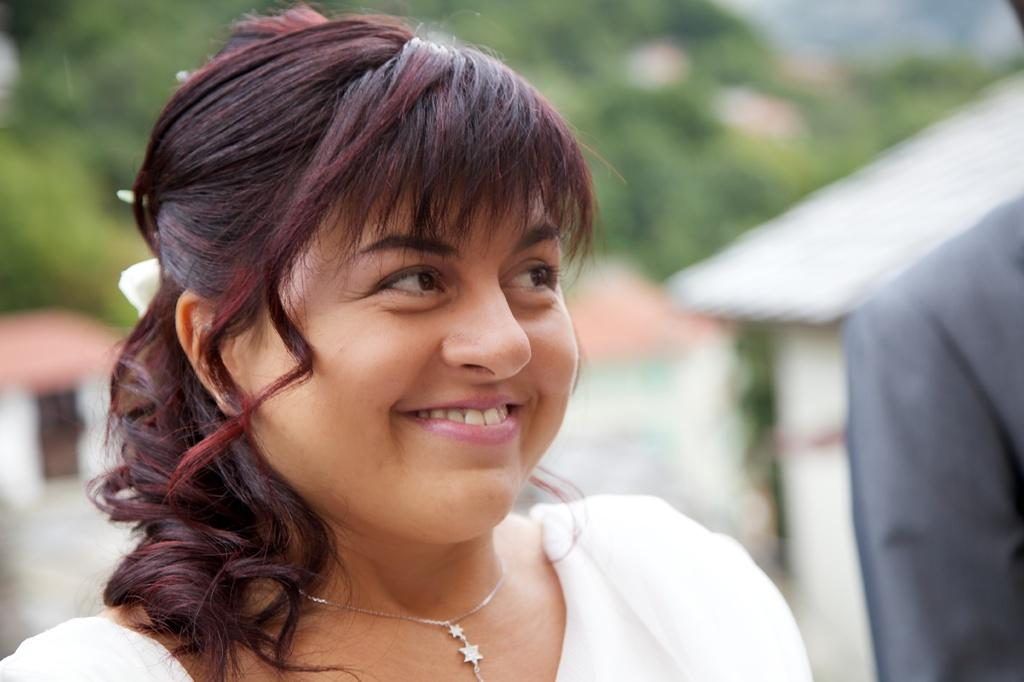What is the main subject of the image? The main subject of the image is a woman. What is the woman wearing in the image? The woman is wearing a white dress and a silver chain. What is the woman's facial expression in the image? The woman is smiling in the image. How is the background of the woman depicted in the image? The background of the woman is blurred in the image. What type of pie is the woman holding in the image? There is no pie present in the image; the woman is not holding anything. 